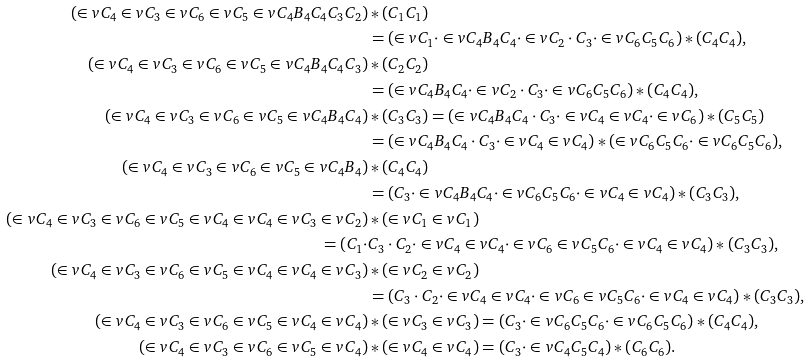<formula> <loc_0><loc_0><loc_500><loc_500>( \in v { C _ { 4 } } \in v { C _ { 3 } } \in v { C _ { 6 } } \in v { C _ { 5 } } \in v { C _ { 4 } } B _ { 4 } C _ { 4 } C _ { 3 } C _ { 2 } ) & * ( C _ { 1 } C _ { 1 } ) \\ & = ( \in v { C _ { 1 } } \cdot \in v { C _ { 4 } } B _ { 4 } C _ { 4 } \cdot \in v { C _ { 2 } } \cdot C _ { 3 } \cdot \in v { C _ { 6 } } C _ { 5 } C _ { 6 } ) * ( C _ { 4 } C _ { 4 } ) , \\ ( \in v { C _ { 4 } } \in v { C _ { 3 } } \in v { C _ { 6 } } \in v { C _ { 5 } } \in v { C _ { 4 } } B _ { 4 } C _ { 4 } C _ { 3 } ) & * ( C _ { 2 } C _ { 2 } ) \\ & = ( \in v { C _ { 4 } } B _ { 4 } C _ { 4 } \cdot \in v { C _ { 2 } } \cdot C _ { 3 } \cdot \in v { C _ { 6 } } C _ { 5 } C _ { 6 } ) * ( C _ { 4 } C _ { 4 } ) , \\ ( \in v { C _ { 4 } } \in v { C _ { 3 } } \in v { C _ { 6 } } \in v { C _ { 5 } } \in v { C _ { 4 } } B _ { 4 } C _ { 4 } ) & * ( C _ { 3 } C _ { 3 } ) = ( \in v { C _ { 4 } } B _ { 4 } C _ { 4 } \cdot C _ { 3 } \cdot \in v { C _ { 4 } } \in v { C _ { 4 } } \cdot \in v { C _ { 6 } } ) * ( C _ { 5 } C _ { 5 } ) \\ & = ( \in v { C _ { 4 } } B _ { 4 } C _ { 4 } \cdot C _ { 3 } \cdot \in v { C _ { 4 } } \in v { C _ { 4 } } ) * ( \in v { C _ { 6 } } C _ { 5 } C _ { 6 } \cdot \in v { C _ { 6 } } C _ { 5 } C _ { 6 } ) , \\ ( \in v { C _ { 4 } } \in v { C _ { 3 } } \in v { C _ { 6 } } \in v { C _ { 5 } } \in v { C _ { 4 } } B _ { 4 } ) & * ( C _ { 4 } C _ { 4 } ) \\ & = ( C _ { 3 } \cdot \in v { C _ { 4 } } B _ { 4 } C _ { 4 } \cdot \in v { C _ { 6 } } C _ { 5 } C _ { 6 } \cdot \in v { C _ { 4 } } \in v { C _ { 4 } } ) * ( C _ { 3 } C _ { 3 } ) , \\ ( \in v { C _ { 4 } } \in v { C _ { 3 } } \in v { C _ { 6 } } \in v { C _ { 5 } } \in v { C _ { 4 } } \in v { C _ { 4 } } \in v { C _ { 3 } } \in v { C _ { 2 } } ) & * ( \in v { C _ { 1 } } \in v { C _ { 1 } } ) \\ = ( C _ { 1 } \cdot & C _ { 3 } \cdot C _ { 2 } \cdot \in v { C _ { 4 } } \in v { C _ { 4 } } \cdot \in v { C _ { 6 } } \in v { C _ { 5 } } C _ { 6 } \cdot \in v { C _ { 4 } } \in v { C _ { 4 } } ) * ( C _ { 3 } C _ { 3 } ) , \\ ( \in v { C _ { 4 } } \in v { C _ { 3 } } \in v { C _ { 6 } } \in v { C _ { 5 } } \in v { C _ { 4 } } \in v { C _ { 4 } } \in v { C _ { 3 } } ) & * ( \in v { C _ { 2 } } \in v { C _ { 2 } } ) \\ & = ( C _ { 3 } \cdot C _ { 2 } \cdot \in v { C _ { 4 } } \in v { C _ { 4 } } \cdot \in v { C _ { 6 } } \in v { C _ { 5 } } C _ { 6 } \cdot \in v { C _ { 4 } } \in v { C _ { 4 } } ) * ( C _ { 3 } C _ { 3 } ) , \\ ( \in v { C _ { 4 } } \in v { C _ { 3 } } \in v { C _ { 6 } } \in v { C _ { 5 } } \in v { C _ { 4 } } \in v { C _ { 4 } } ) & * ( \in v { C _ { 3 } } \in v { C _ { 3 } } ) = ( C _ { 3 } \cdot \in v { C _ { 6 } } C _ { 5 } C _ { 6 } \cdot \in v { C _ { 6 } } C _ { 5 } C _ { 6 } ) * ( C _ { 4 } C _ { 4 } ) , \\ ( \in v { C _ { 4 } } \in v { C _ { 3 } } \in v { C _ { 6 } } \in v { C _ { 5 } } \in v { C _ { 4 } } ) & * ( \in v { C _ { 4 } } \in v { C _ { 4 } } ) = ( C _ { 3 } \cdot \in v { C _ { 4 } } C _ { 5 } C _ { 4 } ) * ( C _ { 6 } C _ { 6 } ) .</formula> 